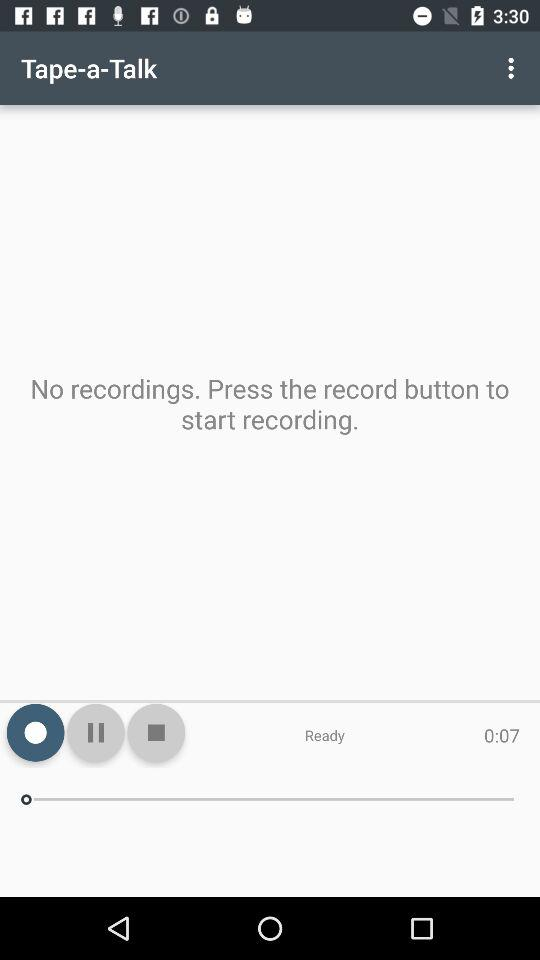What is the duration of the audio? The duration is 7 seconds. 